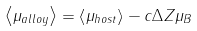<formula> <loc_0><loc_0><loc_500><loc_500>\left < \mu _ { a l l o y } \right > = \left < \mu _ { h o s t } \right > - c \Delta Z \mu _ { B }</formula> 